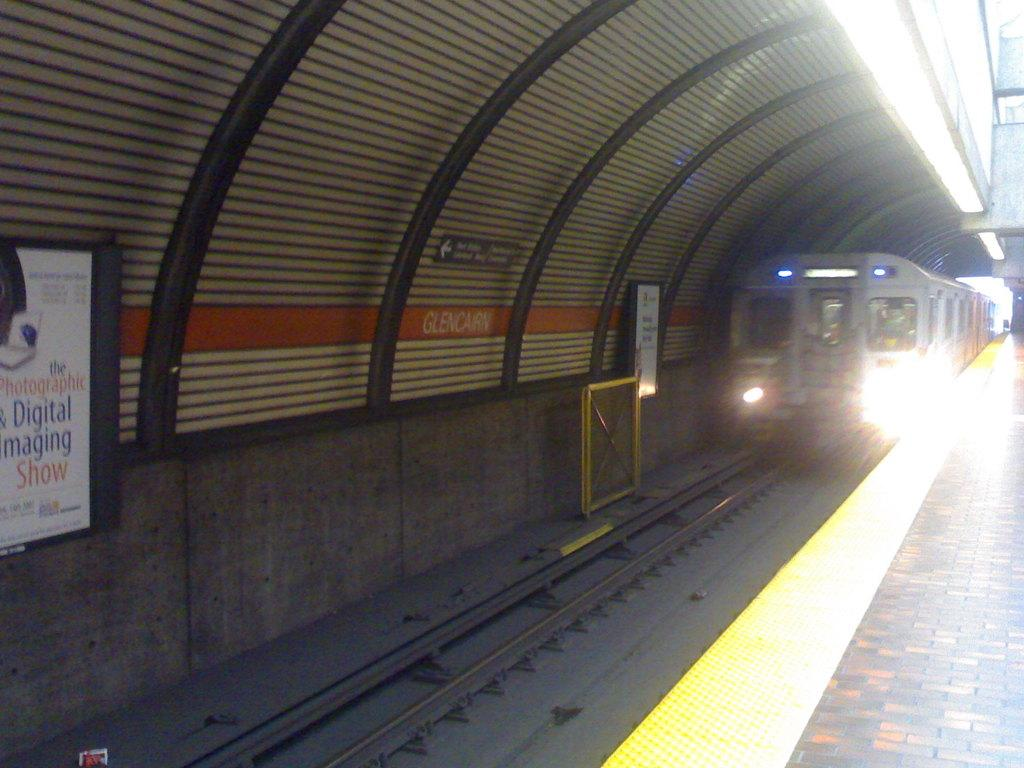What is the main subject of the image? The main subject of the image is a train. Where is the train located in the image? The train is on a railway track. What can be seen on the right side of the image? There is a platform on the right side of the image. What is present on the left side of the image? There is a banner and a shelter on the left side of the image. What type of tray is being used to serve food on the train in the image? There is no tray or food being served in the image; it only shows a train on a railway track with a platform, banner, and shelter nearby. 